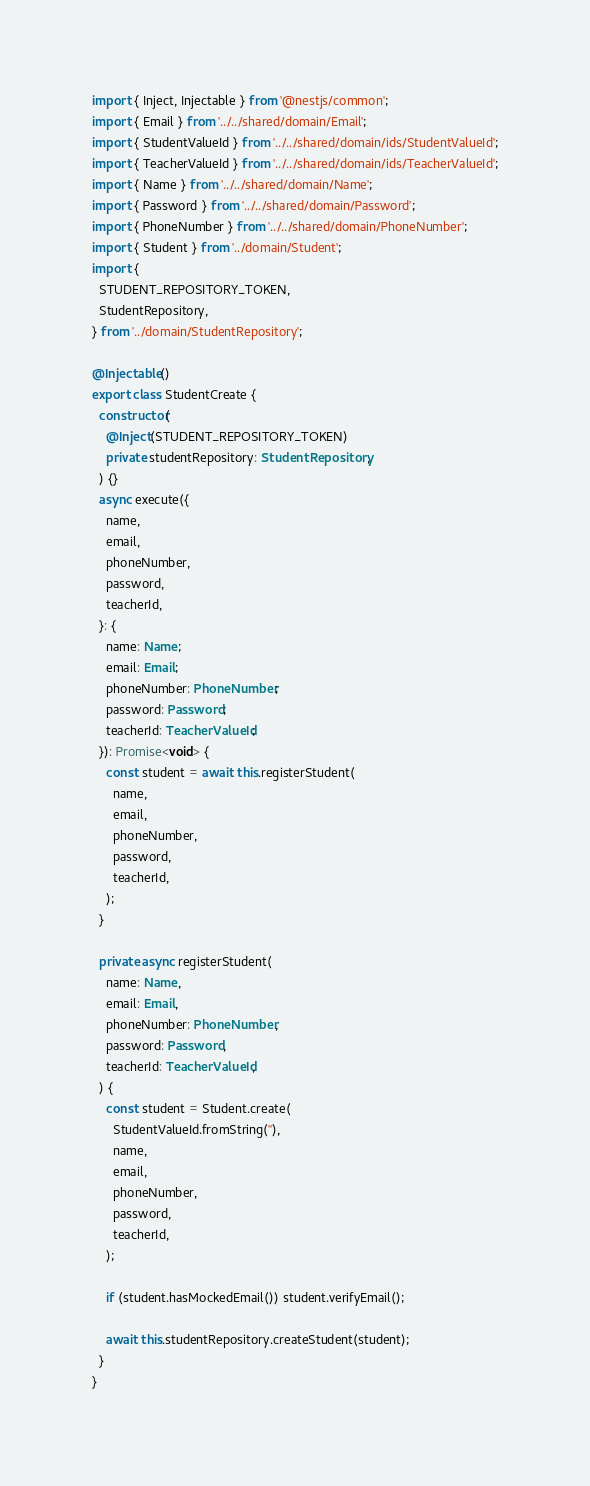Convert code to text. <code><loc_0><loc_0><loc_500><loc_500><_TypeScript_>import { Inject, Injectable } from '@nestjs/common';
import { Email } from '../../shared/domain/Email';
import { StudentValueId } from '../../shared/domain/ids/StudentValueId';
import { TeacherValueId } from '../../shared/domain/ids/TeacherValueId';
import { Name } from '../../shared/domain/Name';
import { Password } from '../../shared/domain/Password';
import { PhoneNumber } from '../../shared/domain/PhoneNumber';
import { Student } from '../domain/Student';
import {
  STUDENT_REPOSITORY_TOKEN,
  StudentRepository,
} from '../domain/StudentRepository';

@Injectable()
export class StudentCreate {
  constructor(
    @Inject(STUDENT_REPOSITORY_TOKEN)
    private studentRepository: StudentRepository,
  ) {}
  async execute({
    name,
    email,
    phoneNumber,
    password,
    teacherId,
  }: {
    name: Name;
    email: Email;
    phoneNumber: PhoneNumber;
    password: Password;
    teacherId: TeacherValueId;
  }): Promise<void> {
    const student = await this.registerStudent(
      name,
      email,
      phoneNumber,
      password,
      teacherId,
    );
  }

  private async registerStudent(
    name: Name,
    email: Email,
    phoneNumber: PhoneNumber,
    password: Password,
    teacherId: TeacherValueId,
  ) {
    const student = Student.create(
      StudentValueId.fromString(''),
      name,
      email,
      phoneNumber,
      password,
      teacherId,
    );

    if (student.hasMockedEmail()) student.verifyEmail();

    await this.studentRepository.createStudent(student);
  }
}
</code> 